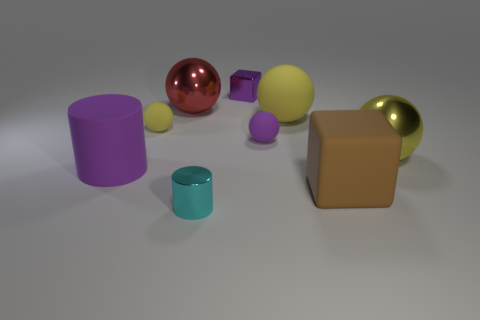How many yellow balls must be subtracted to get 1 yellow balls? 2 Subtract all rubber balls. How many balls are left? 2 Subtract all green cylinders. How many yellow balls are left? 3 Add 1 large red balls. How many objects exist? 10 Subtract all spheres. How many objects are left? 4 Subtract all red spheres. How many spheres are left? 4 Subtract 0 red cylinders. How many objects are left? 9 Subtract 1 spheres. How many spheres are left? 4 Subtract all green cubes. Subtract all brown spheres. How many cubes are left? 2 Subtract all small blue metal spheres. Subtract all small yellow rubber things. How many objects are left? 8 